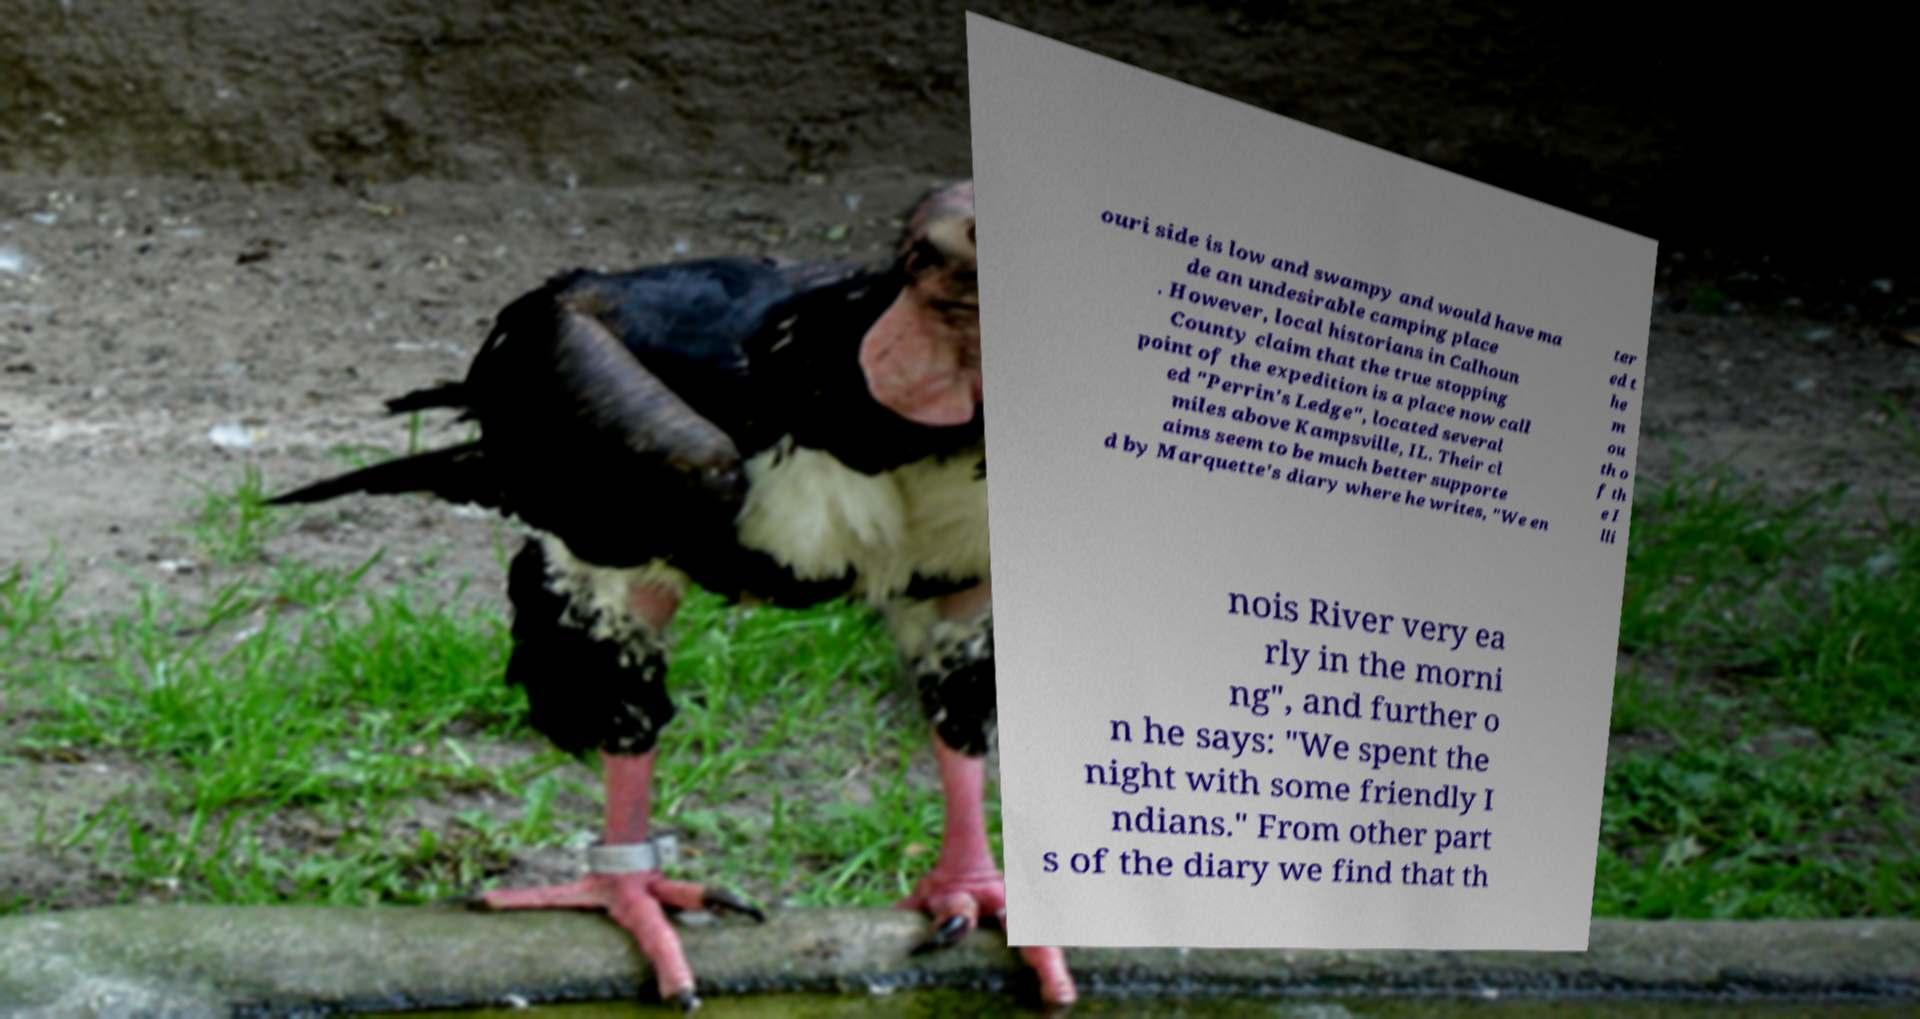Could you assist in decoding the text presented in this image and type it out clearly? ouri side is low and swampy and would have ma de an undesirable camping place . However, local historians in Calhoun County claim that the true stopping point of the expedition is a place now call ed "Perrin's Ledge", located several miles above Kampsville, IL. Their cl aims seem to be much better supporte d by Marquette's diary where he writes, "We en ter ed t he m ou th o f th e I lli nois River very ea rly in the morni ng", and further o n he says: "We spent the night with some friendly I ndians." From other part s of the diary we find that th 